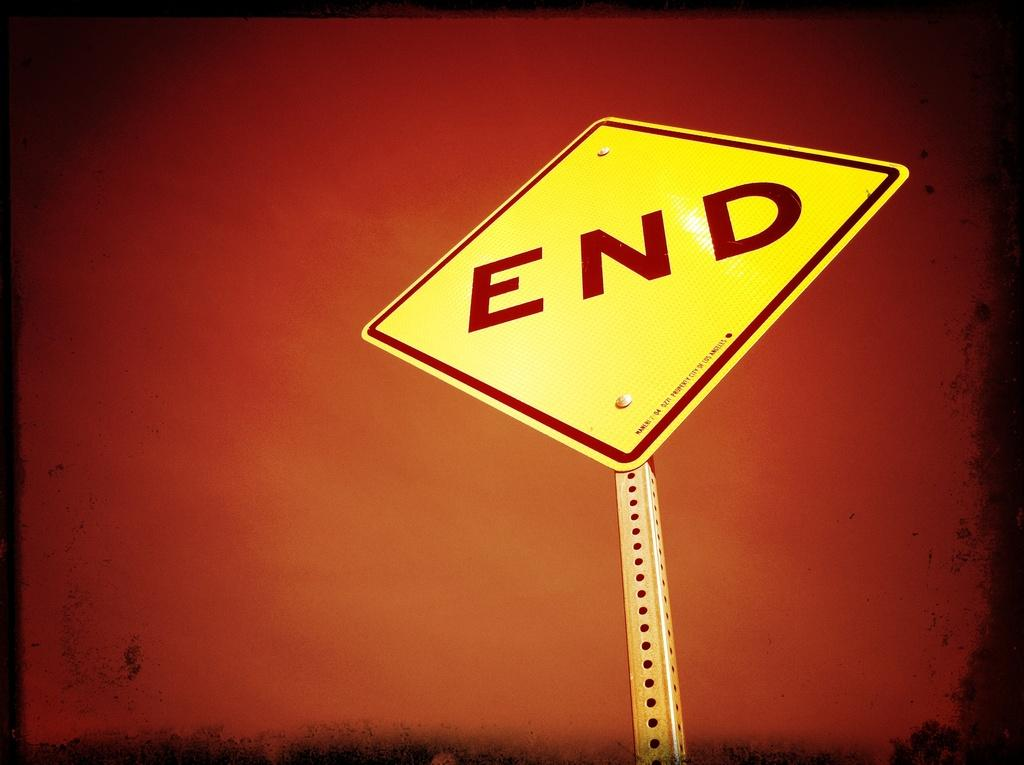<image>
Summarize the visual content of the image. A road sign that is marked END is shown here. 